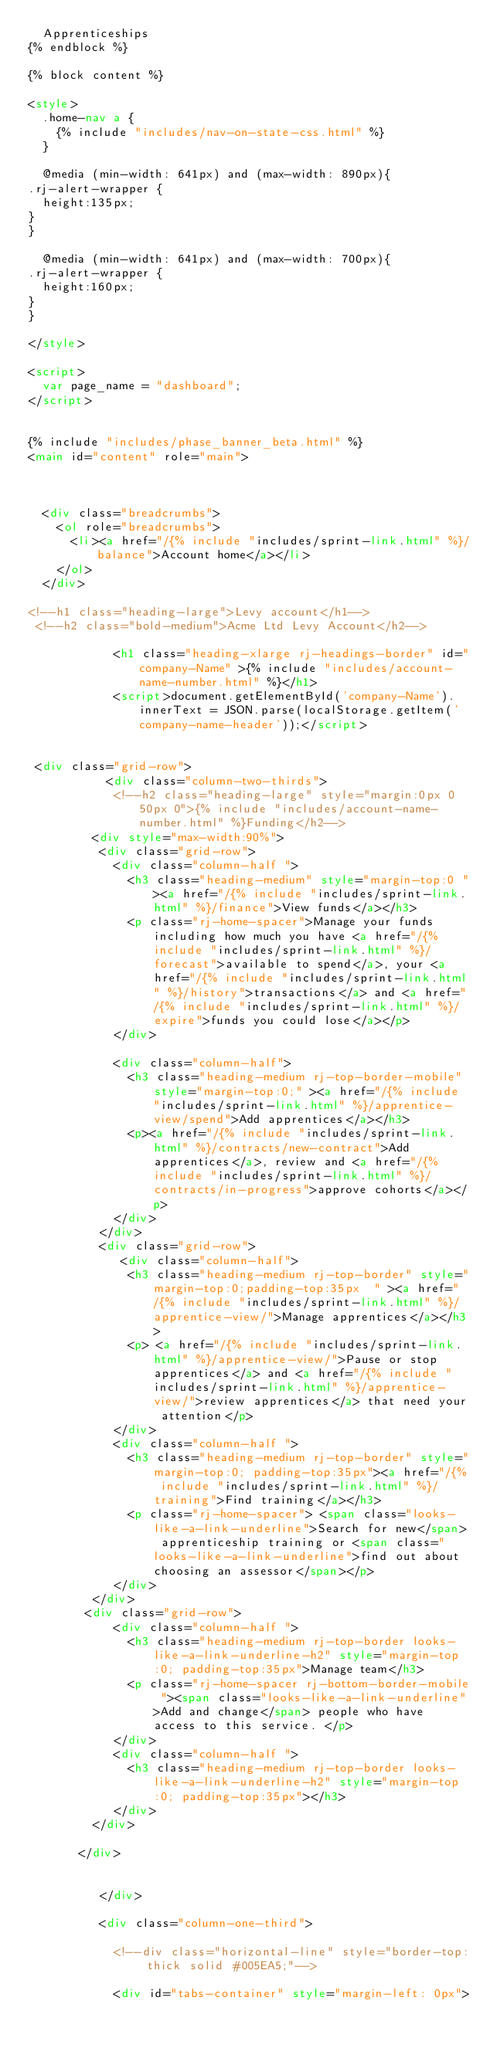<code> <loc_0><loc_0><loc_500><loc_500><_HTML_>  Apprenticeships
{% endblock %}

{% block content %}

<style>
  .home-nav a {
    {% include "includes/nav-on-state-css.html" %}
  }

  @media (min-width: 641px) and (max-width: 890px){
.rj-alert-wrapper {
  height:135px;
}
}

  @media (min-width: 641px) and (max-width: 700px){
.rj-alert-wrapper {
  height:160px;
}
}

</style>

<script>
  var page_name = "dashboard";
</script>


{% include "includes/phase_banner_beta.html" %}
<main id="content" role="main">



  <div class="breadcrumbs">
    <ol role="breadcrumbs">
      <li><a href="/{% include "includes/sprint-link.html" %}/balance">Account home</a></li>
    </ol>
  </div>

<!--h1 class="heading-large">Levy account</h1-->
 <!--h2 class="bold-medium">Acme Ltd Levy Account</h2-->

            <h1 class="heading-xlarge rj-headings-border" id="company-Name" >{% include "includes/account-name-number.html" %}</h1>
            <script>document.getElementById('company-Name').innerText = JSON.parse(localStorage.getItem('company-name-header'));</script>


 <div class="grid-row">
           <div class="column-two-thirds">
            <!--h2 class="heading-large" style="margin:0px 0 50px 0">{% include "includes/account-name-number.html" %}Funding</h2-->
         <div style="max-width:90%">
          <div class="grid-row">
            <div class="column-half ">
              <h3 class="heading-medium" style="margin-top:0 "><a href="/{% include "includes/sprint-link.html" %}/finance">View funds</a></h3>
              <p class="rj-home-spacer">Manage your funds including how much you have <a href="/{% include "includes/sprint-link.html" %}/forecast">available to spend</a>, your <a href="/{% include "includes/sprint-link.html" %}/history">transactions</a> and <a href="/{% include "includes/sprint-link.html" %}/expire">funds you could lose</a></p>
            </div>

            <div class="column-half">
              <h3 class="heading-medium rj-top-border-mobile" style="margin-top:0;" ><a href="/{% include "includes/sprint-link.html" %}/apprentice-view/spend">Add apprentices</a></h3>
              <p><a href="/{% include "includes/sprint-link.html" %}/contracts/new-contract">Add apprentices</a>, review and <a href="/{% include "includes/sprint-link.html" %}/contracts/in-progress">approve cohorts</a></p>
            </div>
          </div> 
          <div class="grid-row">
             <div class="column-half">
              <h3 class="heading-medium rj-top-border" style="margin-top:0;padding-top:35px  " ><a href="/{% include "includes/sprint-link.html" %}/apprentice-view/">Manage apprentices</a></h3>
              <p> <a href="/{% include "includes/sprint-link.html" %}/apprentice-view/">Pause or stop apprentices</a> and <a href="/{% include "includes/sprint-link.html" %}/apprentice-view/">review apprentices</a> that need your attention</p>
            </div>
            <div class="column-half ">
              <h3 class="heading-medium rj-top-border" style="margin-top:0; padding-top:35px"><a href="/{% include "includes/sprint-link.html" %}/training">Find training</a></h3>
              <p class="rj-home-spacer"> <span class="looks-like-a-link-underline">Search for new</span> apprenticeship training or <span class="looks-like-a-link-underline">find out about choosing an assessor</span></p>
            </div>
         </div>
        <div class="grid-row">
            <div class="column-half ">
              <h3 class="heading-medium rj-top-border looks-like-a-link-underline-h2" style="margin-top:0; padding-top:35px">Manage team</h3>
              <p class="rj-home-spacer rj-bottom-border-mobile "><span class="looks-like-a-link-underline">Add and change</span> people who have access to this service. </p>
            </div>
            <div class="column-half ">
              <h3 class="heading-medium rj-top-border looks-like-a-link-underline-h2" style="margin-top:0; padding-top:35px"></h3>
            </div>
         </div>

       </div>


          </div>

          <div class="column-one-third">

            <!--div class="horizontal-line" style="border-top: thick solid #005EA5;"-->

            <div id="tabs-container" style="margin-left: 0px"></code> 